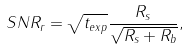Convert formula to latex. <formula><loc_0><loc_0><loc_500><loc_500>S N R _ { r } = \sqrt { t _ { e x p } } \frac { R _ { s } } { \sqrt { R _ { s } + R _ { b } } } ,</formula> 